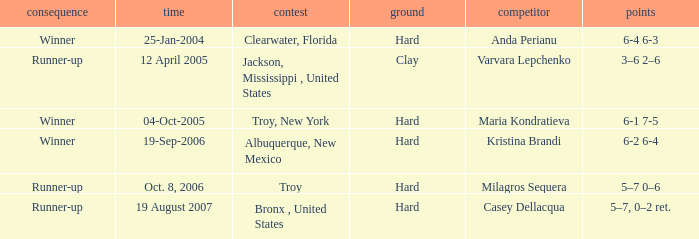Where was the tournament played on Oct. 8, 2006? Troy. 